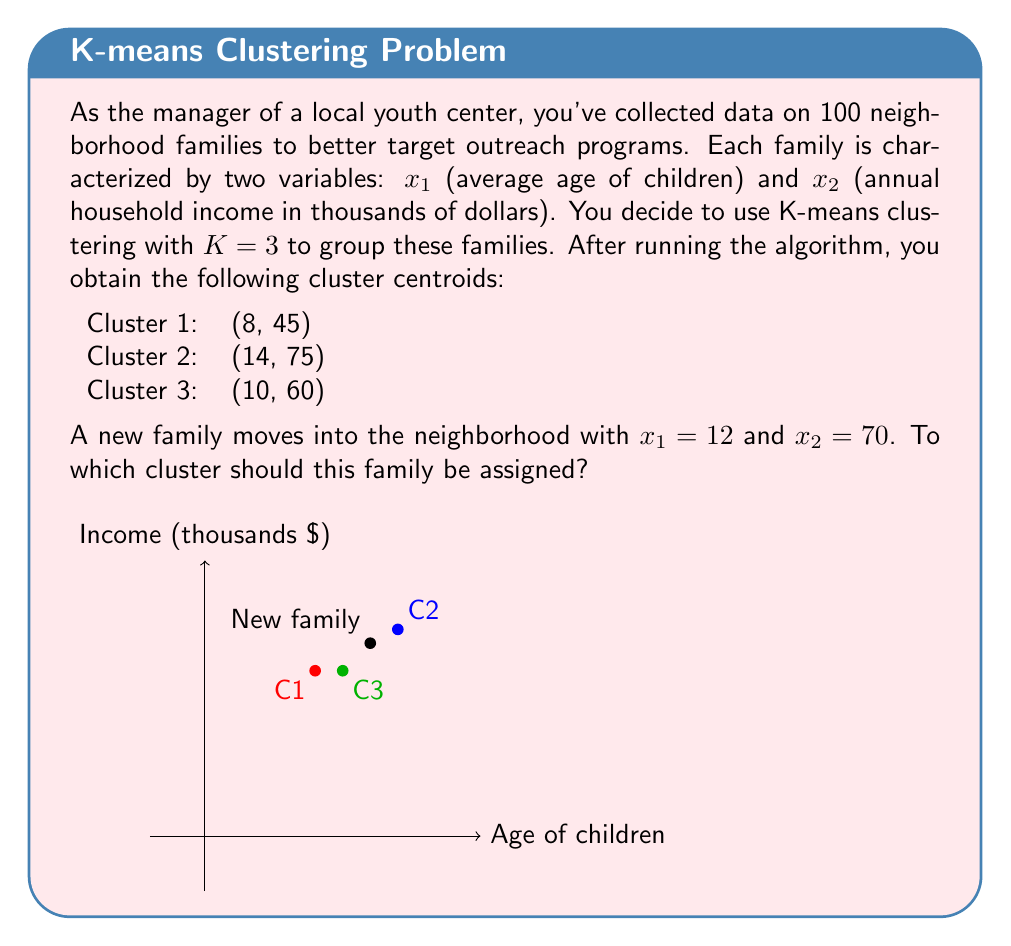Show me your answer to this math problem. To determine which cluster the new family should be assigned to, we need to calculate the Euclidean distance between the new family's data point and each cluster centroid. The cluster with the smallest distance is the one to which the new family should be assigned.

Let's calculate the distance to each centroid:

1) For Cluster 1 (C1):
   $$d_1 = \sqrt{(12-8)^2 + (70-45)^2} = \sqrt{16 + 625} = \sqrt{641} \approx 25.32$$

2) For Cluster 2 (C2):
   $$d_2 = \sqrt{(12-14)^2 + (70-75)^2} = \sqrt{4 + 25} = \sqrt{29} \approx 5.39$$

3) For Cluster 3 (C3):
   $$d_3 = \sqrt{(12-10)^2 + (70-60)^2} = \sqrt{4 + 100} = \sqrt{104} \approx 10.20$$

The smallest distance is $d_2 \approx 5.39$, which corresponds to Cluster 2.

Therefore, the new family should be assigned to Cluster 2.
Answer: Cluster 2 